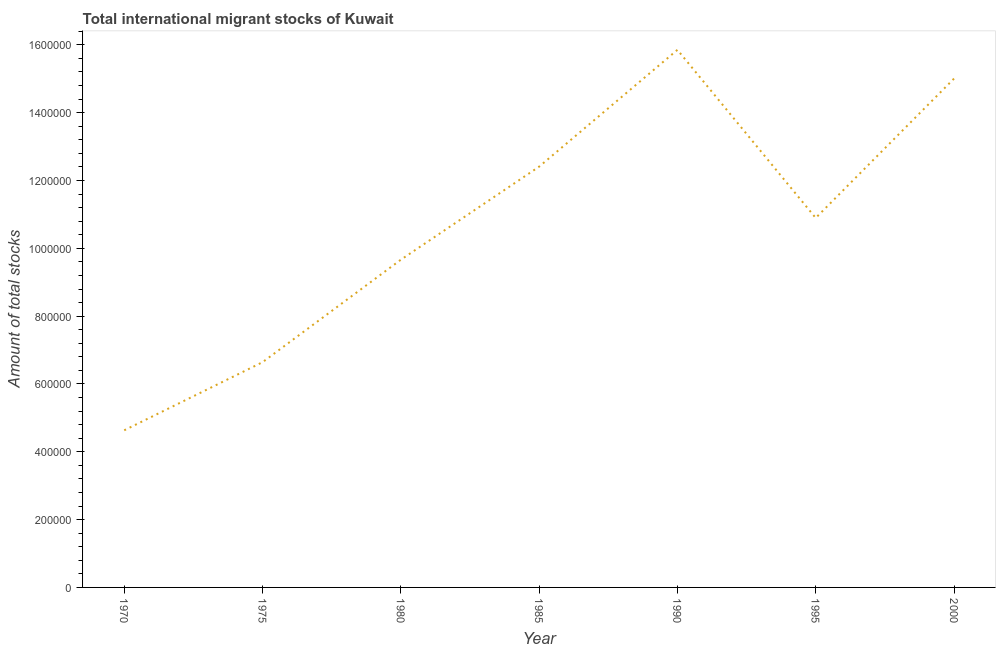What is the total number of international migrant stock in 2000?
Offer a very short reply. 1.50e+06. Across all years, what is the maximum total number of international migrant stock?
Offer a very short reply. 1.59e+06. Across all years, what is the minimum total number of international migrant stock?
Ensure brevity in your answer.  4.63e+05. What is the sum of the total number of international migrant stock?
Provide a succinct answer. 7.51e+06. What is the difference between the total number of international migrant stock in 1970 and 1990?
Make the answer very short. -1.12e+06. What is the average total number of international migrant stock per year?
Your response must be concise. 1.07e+06. What is the median total number of international migrant stock?
Your response must be concise. 1.09e+06. Do a majority of the years between 1980 and 2000 (inclusive) have total number of international migrant stock greater than 1280000 ?
Your answer should be compact. No. What is the ratio of the total number of international migrant stock in 1975 to that in 1980?
Give a very brief answer. 0.69. What is the difference between the highest and the second highest total number of international migrant stock?
Your answer should be compact. 8.48e+04. Is the sum of the total number of international migrant stock in 1980 and 2000 greater than the maximum total number of international migrant stock across all years?
Your response must be concise. Yes. What is the difference between the highest and the lowest total number of international migrant stock?
Provide a short and direct response. 1.12e+06. How many lines are there?
Offer a terse response. 1. What is the difference between two consecutive major ticks on the Y-axis?
Provide a short and direct response. 2.00e+05. Are the values on the major ticks of Y-axis written in scientific E-notation?
Ensure brevity in your answer.  No. What is the title of the graph?
Offer a terse response. Total international migrant stocks of Kuwait. What is the label or title of the X-axis?
Offer a terse response. Year. What is the label or title of the Y-axis?
Provide a succinct answer. Amount of total stocks. What is the Amount of total stocks in 1970?
Provide a succinct answer. 4.63e+05. What is the Amount of total stocks of 1975?
Ensure brevity in your answer.  6.64e+05. What is the Amount of total stocks in 1980?
Keep it short and to the point. 9.66e+05. What is the Amount of total stocks in 1985?
Offer a very short reply. 1.24e+06. What is the Amount of total stocks of 1990?
Provide a short and direct response. 1.59e+06. What is the Amount of total stocks in 1995?
Provide a short and direct response. 1.09e+06. What is the Amount of total stocks in 2000?
Offer a terse response. 1.50e+06. What is the difference between the Amount of total stocks in 1970 and 1975?
Provide a succinct answer. -2.01e+05. What is the difference between the Amount of total stocks in 1970 and 1980?
Your response must be concise. -5.03e+05. What is the difference between the Amount of total stocks in 1970 and 1985?
Your answer should be very brief. -7.77e+05. What is the difference between the Amount of total stocks in 1970 and 1990?
Make the answer very short. -1.12e+06. What is the difference between the Amount of total stocks in 1970 and 1995?
Your answer should be very brief. -6.26e+05. What is the difference between the Amount of total stocks in 1970 and 2000?
Provide a short and direct response. -1.04e+06. What is the difference between the Amount of total stocks in 1975 and 1980?
Provide a succinct answer. -3.02e+05. What is the difference between the Amount of total stocks in 1975 and 1985?
Provide a succinct answer. -5.77e+05. What is the difference between the Amount of total stocks in 1975 and 1990?
Offer a very short reply. -9.21e+05. What is the difference between the Amount of total stocks in 1975 and 1995?
Make the answer very short. -4.25e+05. What is the difference between the Amount of total stocks in 1975 and 2000?
Your answer should be very brief. -8.36e+05. What is the difference between the Amount of total stocks in 1980 and 1985?
Give a very brief answer. -2.74e+05. What is the difference between the Amount of total stocks in 1980 and 1990?
Give a very brief answer. -6.19e+05. What is the difference between the Amount of total stocks in 1980 and 1995?
Provide a short and direct response. -1.23e+05. What is the difference between the Amount of total stocks in 1980 and 2000?
Offer a terse response. -5.34e+05. What is the difference between the Amount of total stocks in 1985 and 1990?
Make the answer very short. -3.44e+05. What is the difference between the Amount of total stocks in 1985 and 1995?
Provide a short and direct response. 1.51e+05. What is the difference between the Amount of total stocks in 1985 and 2000?
Provide a succinct answer. -2.60e+05. What is the difference between the Amount of total stocks in 1990 and 1995?
Make the answer very short. 4.96e+05. What is the difference between the Amount of total stocks in 1990 and 2000?
Your answer should be very brief. 8.48e+04. What is the difference between the Amount of total stocks in 1995 and 2000?
Offer a terse response. -4.11e+05. What is the ratio of the Amount of total stocks in 1970 to that in 1975?
Your answer should be very brief. 0.7. What is the ratio of the Amount of total stocks in 1970 to that in 1980?
Ensure brevity in your answer.  0.48. What is the ratio of the Amount of total stocks in 1970 to that in 1985?
Your answer should be very brief. 0.37. What is the ratio of the Amount of total stocks in 1970 to that in 1990?
Make the answer very short. 0.29. What is the ratio of the Amount of total stocks in 1970 to that in 1995?
Offer a terse response. 0.42. What is the ratio of the Amount of total stocks in 1970 to that in 2000?
Make the answer very short. 0.31. What is the ratio of the Amount of total stocks in 1975 to that in 1980?
Keep it short and to the point. 0.69. What is the ratio of the Amount of total stocks in 1975 to that in 1985?
Provide a succinct answer. 0.54. What is the ratio of the Amount of total stocks in 1975 to that in 1990?
Provide a short and direct response. 0.42. What is the ratio of the Amount of total stocks in 1975 to that in 1995?
Your answer should be very brief. 0.61. What is the ratio of the Amount of total stocks in 1975 to that in 2000?
Make the answer very short. 0.44. What is the ratio of the Amount of total stocks in 1980 to that in 1985?
Provide a succinct answer. 0.78. What is the ratio of the Amount of total stocks in 1980 to that in 1990?
Keep it short and to the point. 0.61. What is the ratio of the Amount of total stocks in 1980 to that in 1995?
Ensure brevity in your answer.  0.89. What is the ratio of the Amount of total stocks in 1980 to that in 2000?
Your answer should be compact. 0.64. What is the ratio of the Amount of total stocks in 1985 to that in 1990?
Make the answer very short. 0.78. What is the ratio of the Amount of total stocks in 1985 to that in 1995?
Give a very brief answer. 1.14. What is the ratio of the Amount of total stocks in 1985 to that in 2000?
Provide a succinct answer. 0.83. What is the ratio of the Amount of total stocks in 1990 to that in 1995?
Your answer should be very brief. 1.46. What is the ratio of the Amount of total stocks in 1990 to that in 2000?
Ensure brevity in your answer.  1.06. What is the ratio of the Amount of total stocks in 1995 to that in 2000?
Give a very brief answer. 0.73. 